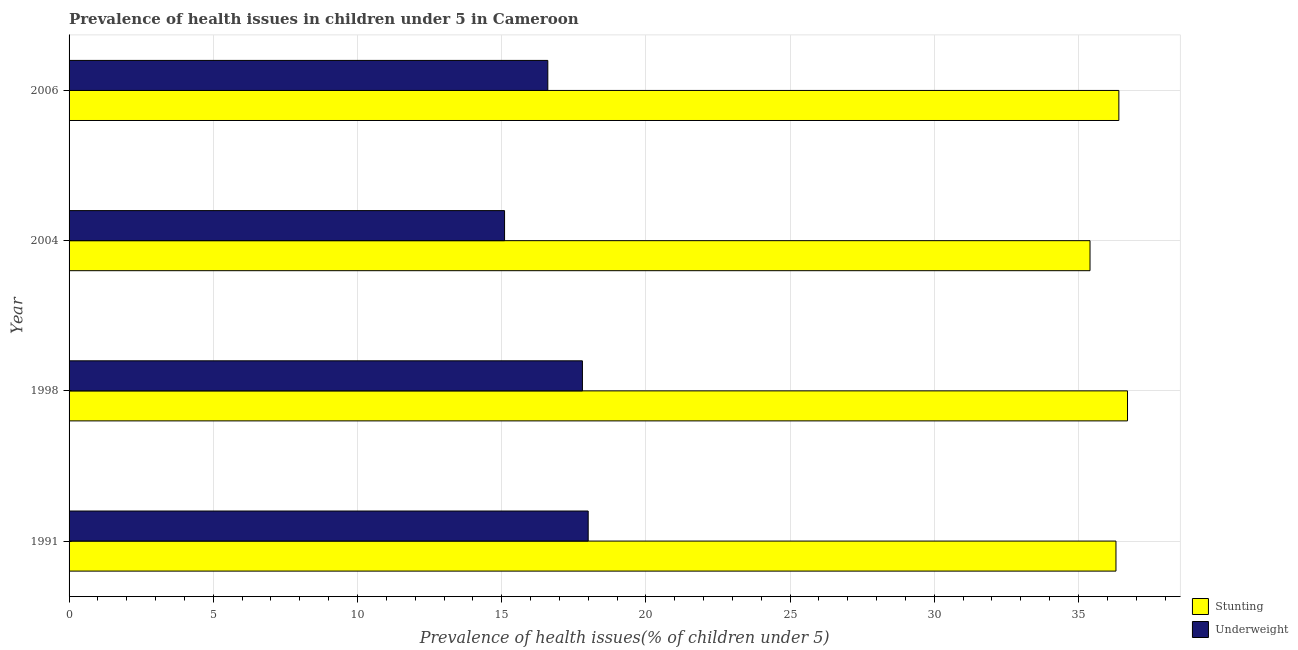How many different coloured bars are there?
Provide a short and direct response. 2. How many groups of bars are there?
Provide a short and direct response. 4. Are the number of bars on each tick of the Y-axis equal?
Give a very brief answer. Yes. What is the label of the 4th group of bars from the top?
Your response must be concise. 1991. What is the percentage of underweight children in 1998?
Provide a succinct answer. 17.8. Across all years, what is the minimum percentage of stunted children?
Provide a succinct answer. 35.4. In which year was the percentage of stunted children minimum?
Your response must be concise. 2004. What is the total percentage of underweight children in the graph?
Give a very brief answer. 67.5. What is the difference between the percentage of underweight children in 1991 and the percentage of stunted children in 2004?
Provide a short and direct response. -17.4. What is the average percentage of underweight children per year?
Ensure brevity in your answer.  16.88. In the year 1991, what is the difference between the percentage of underweight children and percentage of stunted children?
Ensure brevity in your answer.  -18.3. In how many years, is the percentage of underweight children greater than 4 %?
Your answer should be compact. 4. What is the ratio of the percentage of stunted children in 1991 to that in 2004?
Give a very brief answer. 1.02. Is the difference between the percentage of underweight children in 1991 and 2006 greater than the difference between the percentage of stunted children in 1991 and 2006?
Your answer should be compact. Yes. What is the difference between the highest and the second highest percentage of stunted children?
Your answer should be compact. 0.3. In how many years, is the percentage of underweight children greater than the average percentage of underweight children taken over all years?
Offer a terse response. 2. What does the 2nd bar from the top in 1998 represents?
Provide a short and direct response. Stunting. What does the 1st bar from the bottom in 2006 represents?
Offer a very short reply. Stunting. How many bars are there?
Ensure brevity in your answer.  8. How many years are there in the graph?
Make the answer very short. 4. What is the difference between two consecutive major ticks on the X-axis?
Your answer should be very brief. 5. Where does the legend appear in the graph?
Your answer should be very brief. Bottom right. What is the title of the graph?
Your response must be concise. Prevalence of health issues in children under 5 in Cameroon. What is the label or title of the X-axis?
Your response must be concise. Prevalence of health issues(% of children under 5). What is the Prevalence of health issues(% of children under 5) of Stunting in 1991?
Ensure brevity in your answer.  36.3. What is the Prevalence of health issues(% of children under 5) of Stunting in 1998?
Provide a short and direct response. 36.7. What is the Prevalence of health issues(% of children under 5) in Underweight in 1998?
Offer a very short reply. 17.8. What is the Prevalence of health issues(% of children under 5) in Stunting in 2004?
Your response must be concise. 35.4. What is the Prevalence of health issues(% of children under 5) in Underweight in 2004?
Provide a succinct answer. 15.1. What is the Prevalence of health issues(% of children under 5) of Stunting in 2006?
Offer a terse response. 36.4. What is the Prevalence of health issues(% of children under 5) of Underweight in 2006?
Offer a terse response. 16.6. Across all years, what is the maximum Prevalence of health issues(% of children under 5) in Stunting?
Offer a very short reply. 36.7. Across all years, what is the minimum Prevalence of health issues(% of children under 5) in Stunting?
Ensure brevity in your answer.  35.4. Across all years, what is the minimum Prevalence of health issues(% of children under 5) in Underweight?
Your response must be concise. 15.1. What is the total Prevalence of health issues(% of children under 5) of Stunting in the graph?
Ensure brevity in your answer.  144.8. What is the total Prevalence of health issues(% of children under 5) in Underweight in the graph?
Offer a very short reply. 67.5. What is the difference between the Prevalence of health issues(% of children under 5) in Stunting in 1991 and that in 2006?
Ensure brevity in your answer.  -0.1. What is the difference between the Prevalence of health issues(% of children under 5) in Underweight in 1991 and that in 2006?
Keep it short and to the point. 1.4. What is the difference between the Prevalence of health issues(% of children under 5) in Underweight in 1998 and that in 2006?
Make the answer very short. 1.2. What is the difference between the Prevalence of health issues(% of children under 5) in Stunting in 1991 and the Prevalence of health issues(% of children under 5) in Underweight in 2004?
Make the answer very short. 21.2. What is the difference between the Prevalence of health issues(% of children under 5) of Stunting in 1991 and the Prevalence of health issues(% of children under 5) of Underweight in 2006?
Your answer should be compact. 19.7. What is the difference between the Prevalence of health issues(% of children under 5) in Stunting in 1998 and the Prevalence of health issues(% of children under 5) in Underweight in 2004?
Offer a terse response. 21.6. What is the difference between the Prevalence of health issues(% of children under 5) in Stunting in 1998 and the Prevalence of health issues(% of children under 5) in Underweight in 2006?
Make the answer very short. 20.1. What is the average Prevalence of health issues(% of children under 5) in Stunting per year?
Provide a succinct answer. 36.2. What is the average Prevalence of health issues(% of children under 5) in Underweight per year?
Provide a short and direct response. 16.88. In the year 1991, what is the difference between the Prevalence of health issues(% of children under 5) of Stunting and Prevalence of health issues(% of children under 5) of Underweight?
Provide a short and direct response. 18.3. In the year 1998, what is the difference between the Prevalence of health issues(% of children under 5) in Stunting and Prevalence of health issues(% of children under 5) in Underweight?
Make the answer very short. 18.9. In the year 2004, what is the difference between the Prevalence of health issues(% of children under 5) of Stunting and Prevalence of health issues(% of children under 5) of Underweight?
Ensure brevity in your answer.  20.3. In the year 2006, what is the difference between the Prevalence of health issues(% of children under 5) in Stunting and Prevalence of health issues(% of children under 5) in Underweight?
Your response must be concise. 19.8. What is the ratio of the Prevalence of health issues(% of children under 5) of Stunting in 1991 to that in 1998?
Give a very brief answer. 0.99. What is the ratio of the Prevalence of health issues(% of children under 5) of Underweight in 1991 to that in 1998?
Make the answer very short. 1.01. What is the ratio of the Prevalence of health issues(% of children under 5) of Stunting in 1991 to that in 2004?
Provide a short and direct response. 1.03. What is the ratio of the Prevalence of health issues(% of children under 5) in Underweight in 1991 to that in 2004?
Make the answer very short. 1.19. What is the ratio of the Prevalence of health issues(% of children under 5) of Stunting in 1991 to that in 2006?
Your answer should be compact. 1. What is the ratio of the Prevalence of health issues(% of children under 5) of Underweight in 1991 to that in 2006?
Make the answer very short. 1.08. What is the ratio of the Prevalence of health issues(% of children under 5) of Stunting in 1998 to that in 2004?
Your answer should be compact. 1.04. What is the ratio of the Prevalence of health issues(% of children under 5) in Underweight in 1998 to that in 2004?
Provide a succinct answer. 1.18. What is the ratio of the Prevalence of health issues(% of children under 5) in Stunting in 1998 to that in 2006?
Make the answer very short. 1.01. What is the ratio of the Prevalence of health issues(% of children under 5) of Underweight in 1998 to that in 2006?
Your response must be concise. 1.07. What is the ratio of the Prevalence of health issues(% of children under 5) in Stunting in 2004 to that in 2006?
Offer a terse response. 0.97. What is the ratio of the Prevalence of health issues(% of children under 5) in Underweight in 2004 to that in 2006?
Your answer should be compact. 0.91. What is the difference between the highest and the second highest Prevalence of health issues(% of children under 5) in Underweight?
Give a very brief answer. 0.2. What is the difference between the highest and the lowest Prevalence of health issues(% of children under 5) of Underweight?
Offer a very short reply. 2.9. 